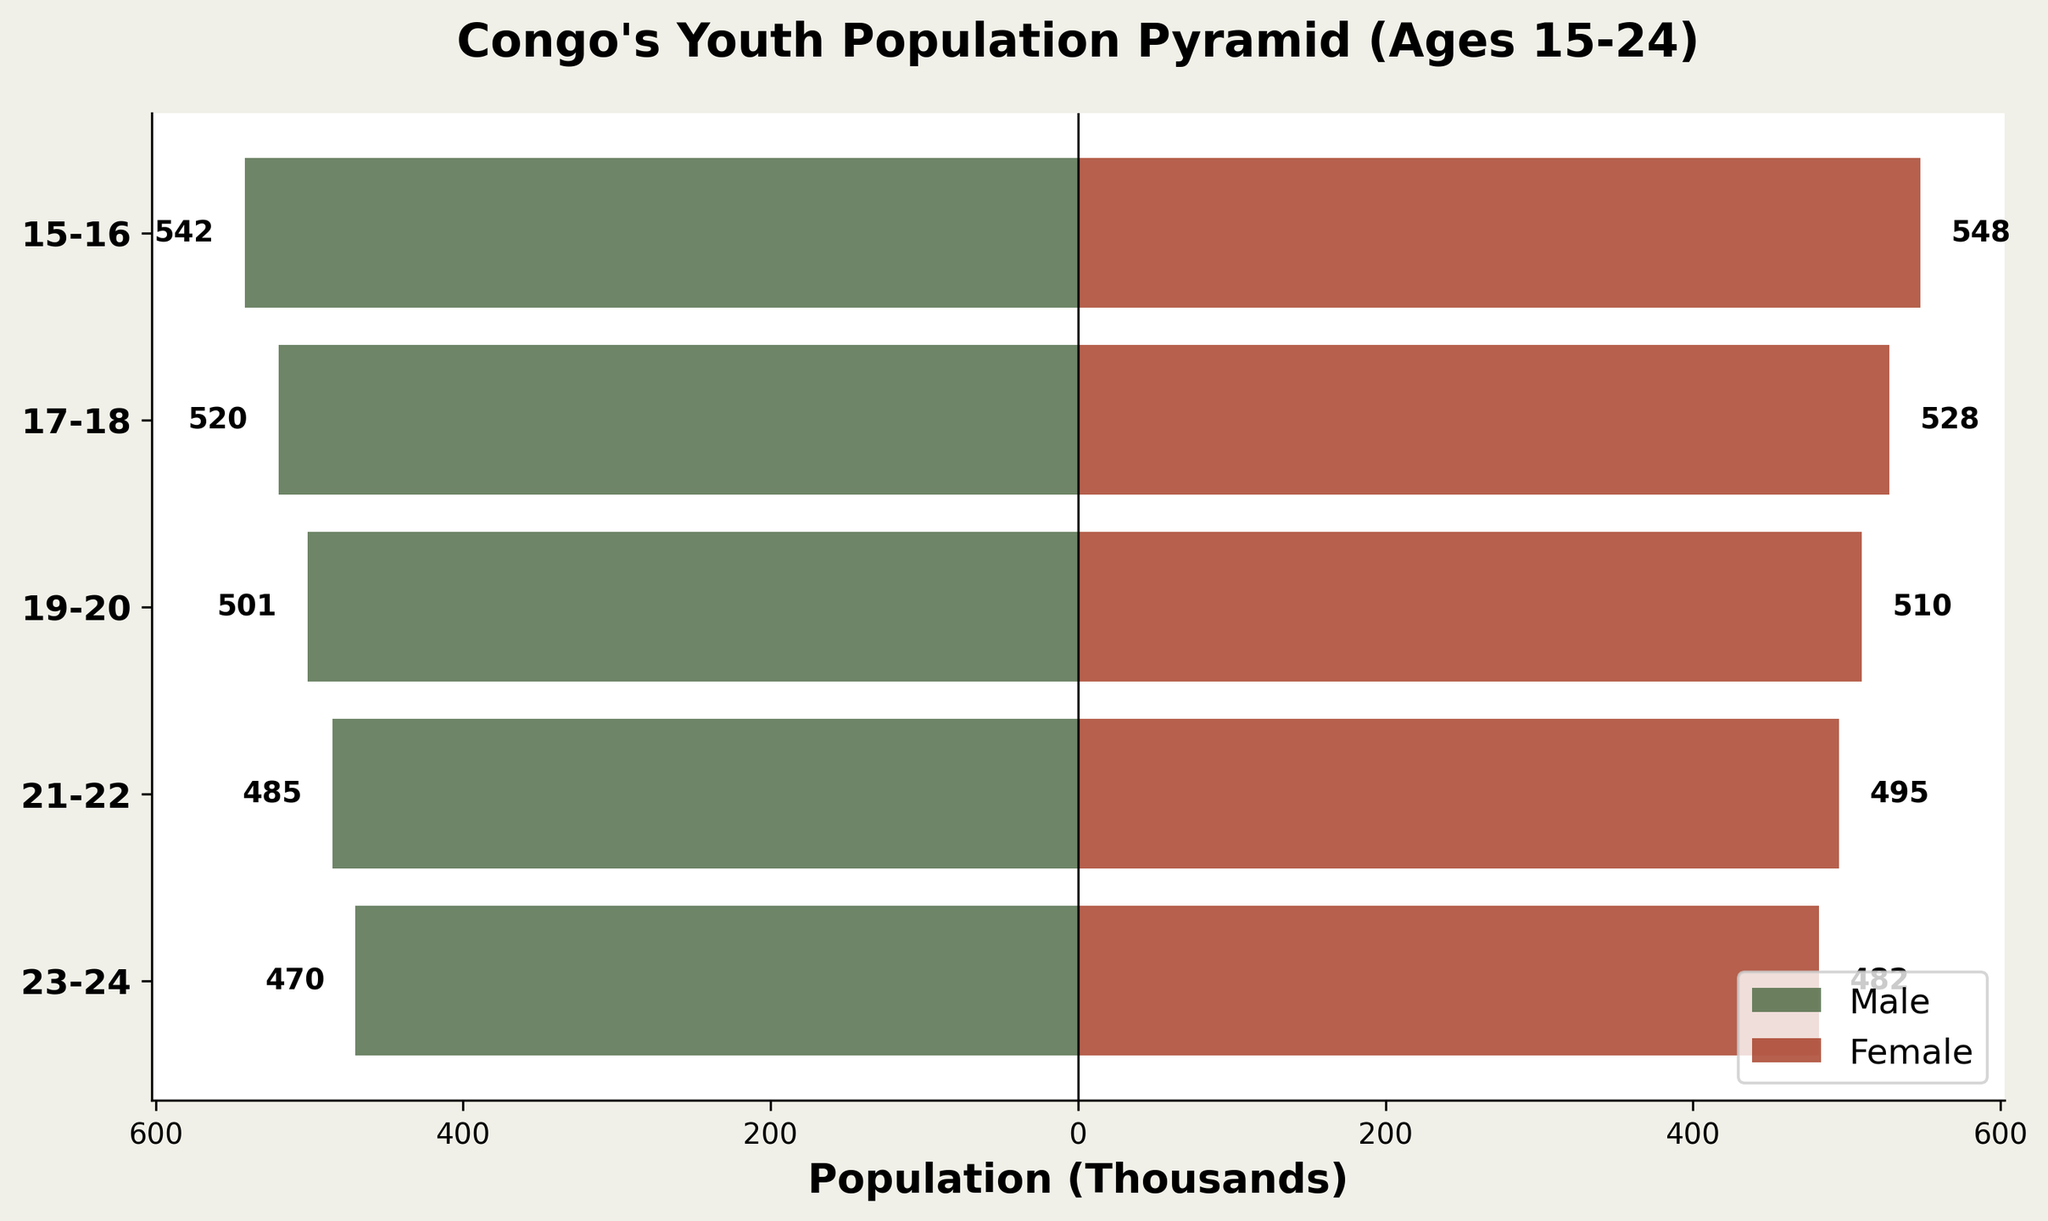What is the title of the figure? The title of the figure is displayed at the top of the chart. It is typically in a larger, bold font to stand out.
Answer: Congo's Youth Population Pyramid (Ages 15-24) Which age group has the highest male population? To determine which age group has the highest male population, look at the length of the left bars (green) representing males. The bar that extends the furthest indicates the highest population.
Answer: 15-16 What is the population difference between males and females in the 23-24 age group? Find the length of the bars for both males and females in the 23-24 age group, then subtract the smaller number (male) from the larger number (female) to get the difference.
Answer: 12,000 Which age group has the smallest gender disparity? To find the age group with the smallest gender disparity, compare the lengths of the male and female bars for each age group. The age group with bars of the closest length has the smallest disparity.
Answer: 23-24 What is the total youth population (ages 15-24) for females? Add up the values of the female population for all age groups to get the total.
Answer: 2,563,000 Compare the male populations in age groups 17-18 and 21-22. Which is larger? Look at the lengths of the male bars for the age groups 17-18 and 21-22. The one with the longer bar represents the larger population.
Answer: 17-18 What is the average female population across all age groups? Calculate the average by summing the female population values for all age groups and dividing by the number of age groups (5).
Answer: 512,600 Is the female population consistently higher than the male population across all age groups? Compare the lengths of the male and female bars for each age group. If the female bars are always longer, then the female population is consistently higher.
Answer: Yes How does the population pyramid suggest potential future workforce trends in Congo? Analyzing the shape and size of the bars for each age group gives insight into the potential future workforce. A balanced or slightly larger male or female population can indicate gender representation in the future workforce.
Answer: Balanced, with slightly more females Which age group has the lowest total youth population? To find the age group with the lowest total youth population, add the male and female populations for each age group and compare. The age group with the smallest combined population is the answer.
Answer: 23-24 